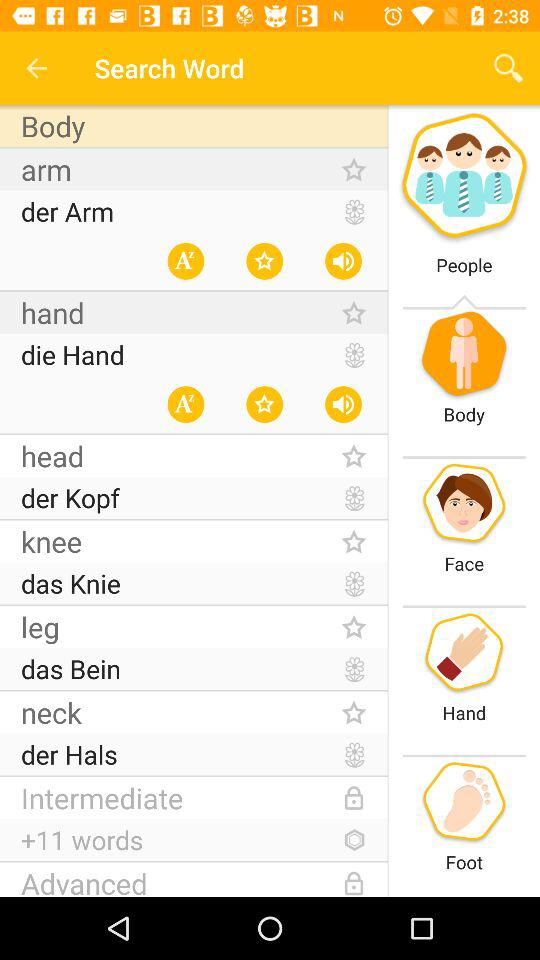What captions have been given to the images? The given captions are people, body, face, hand and foot. 